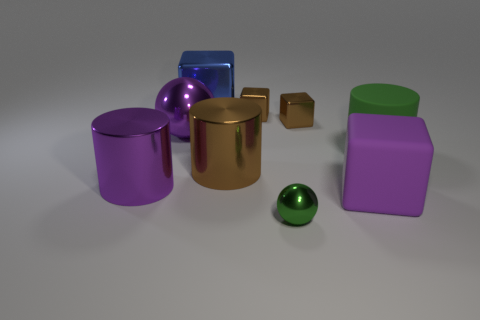Is the brown cylinder behind the tiny ball made of the same material as the tiny ball?
Offer a terse response. Yes. Are any blue rubber spheres visible?
Provide a short and direct response. No. There is another tiny ball that is the same material as the purple sphere; what is its color?
Your answer should be very brief. Green. What color is the thing right of the matte thing on the left side of the rubber object that is on the right side of the purple block?
Provide a succinct answer. Green. There is a purple cube; does it have the same size as the shiny sphere in front of the green matte cylinder?
Offer a very short reply. No. How many things are either big metallic objects that are in front of the green matte cylinder or big objects that are on the right side of the blue object?
Ensure brevity in your answer.  4. What is the shape of the brown object that is the same size as the purple metallic cylinder?
Provide a short and direct response. Cylinder. What shape is the purple object that is right of the shiny sphere that is on the right side of the big metallic block behind the green matte thing?
Give a very brief answer. Cube. Is the number of green matte things that are to the left of the large brown shiny cylinder the same as the number of large shiny cylinders?
Offer a very short reply. No. Do the matte cube and the purple metallic ball have the same size?
Offer a very short reply. Yes. 